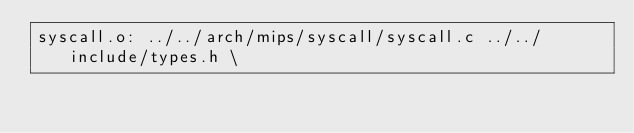<code> <loc_0><loc_0><loc_500><loc_500><_C_>syscall.o: ../../arch/mips/syscall/syscall.c ../../include/types.h \</code> 